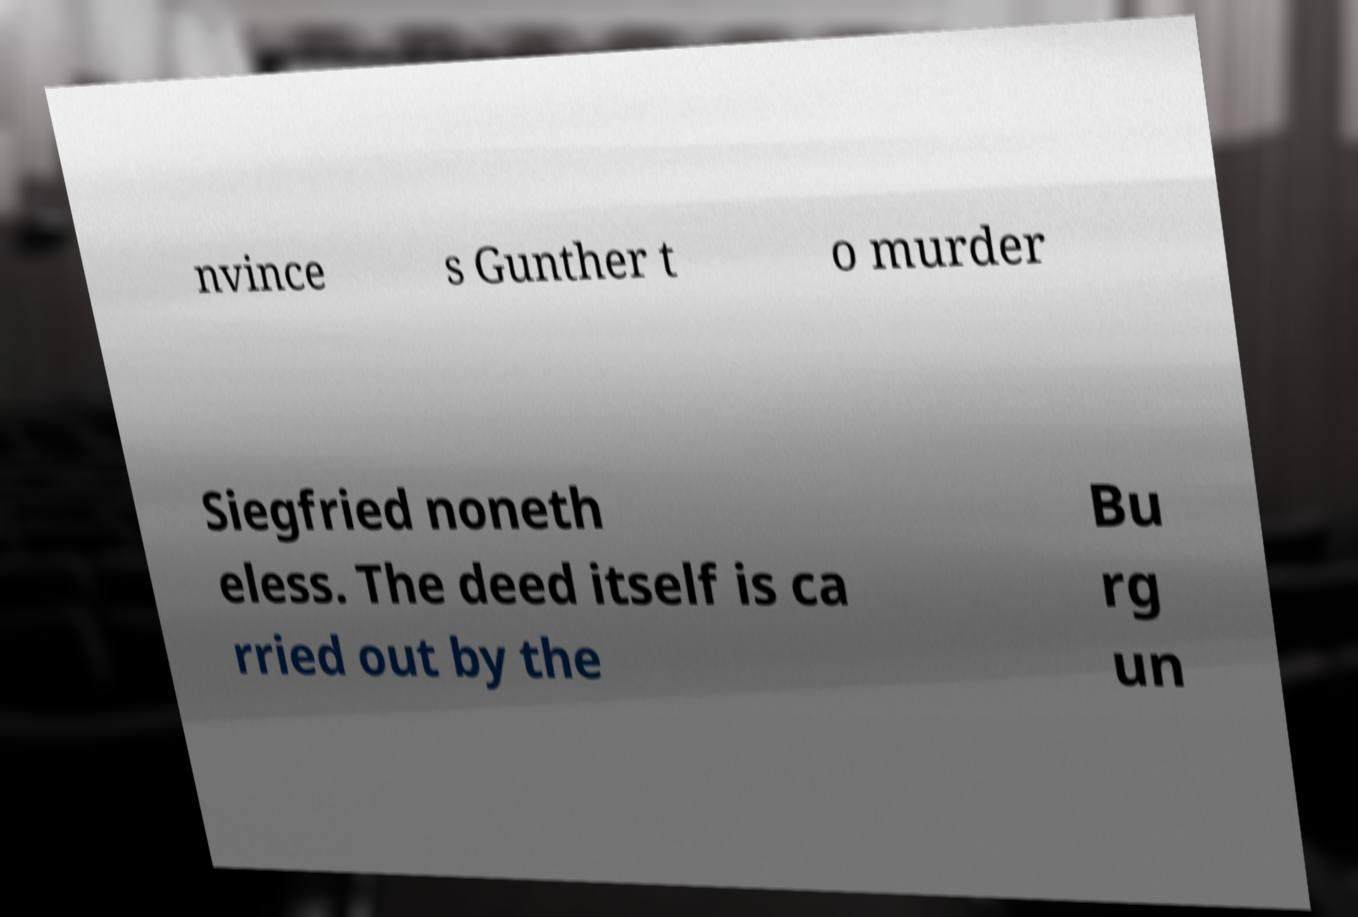Can you read and provide the text displayed in the image?This photo seems to have some interesting text. Can you extract and type it out for me? nvince s Gunther t o murder Siegfried noneth eless. The deed itself is ca rried out by the Bu rg un 